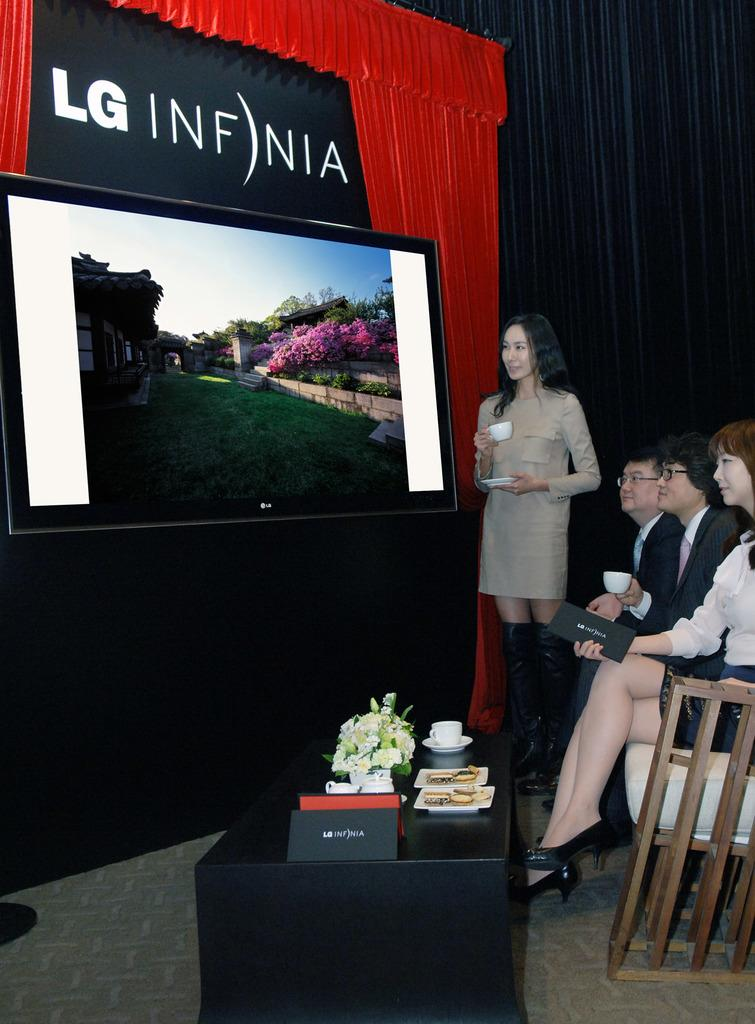<image>
Provide a brief description of the given image. People are drinking tea and watching a presentation at an LG event. 